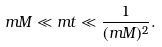Convert formula to latex. <formula><loc_0><loc_0><loc_500><loc_500>m M \ll m t \ll \frac { 1 } { ( m M ) ^ { 2 } } .</formula> 